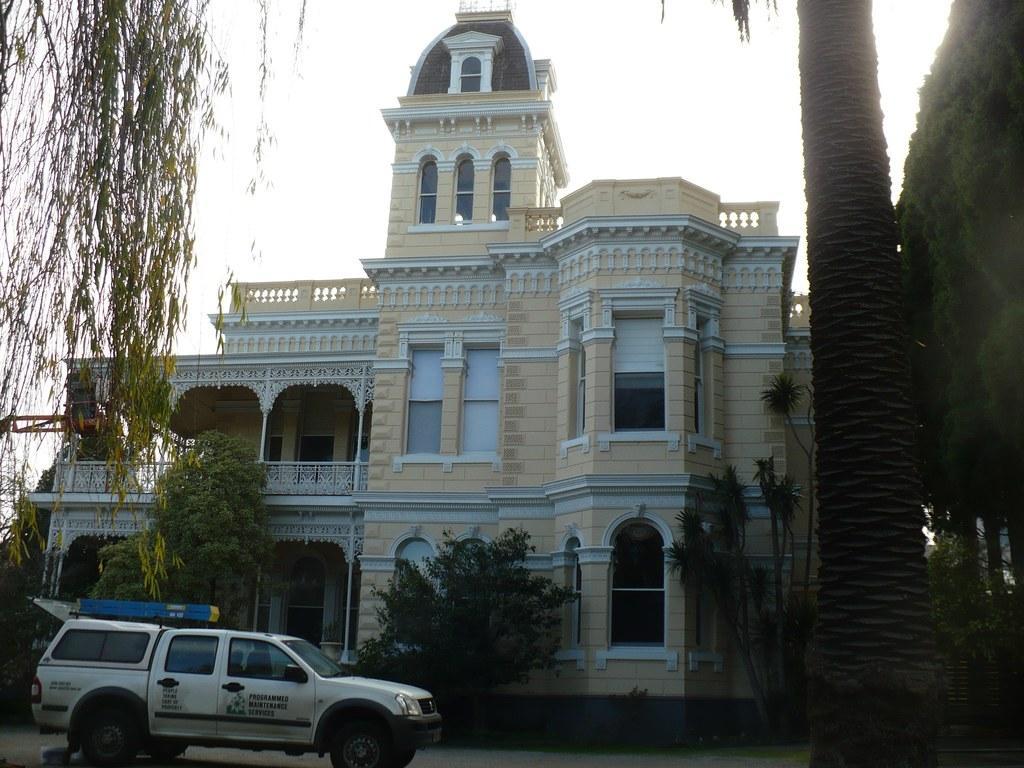Describe this image in one or two sentences. In this picture we can see a vehicle on the ground, trees, building with windows and in the background we can see the sky. 